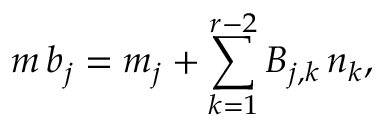Convert formula to latex. <formula><loc_0><loc_0><loc_500><loc_500>m \, b _ { j } = m _ { j } + \sum _ { k = 1 } ^ { r - 2 } B _ { j , k } \, n _ { k } ,</formula> 